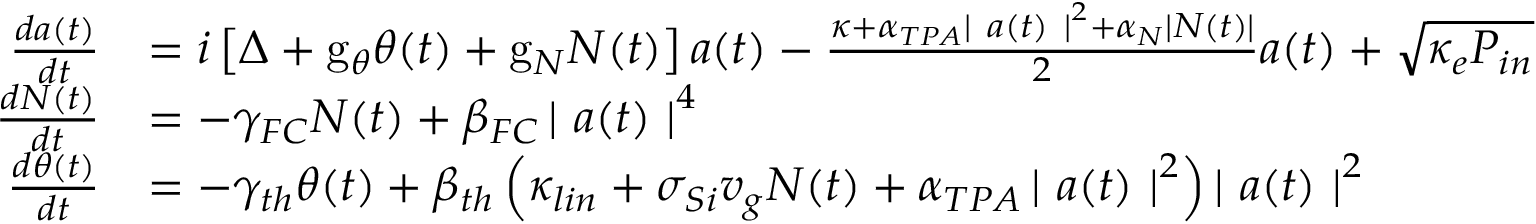Convert formula to latex. <formula><loc_0><loc_0><loc_500><loc_500>\begin{array} { r l } { \frac { d a ( t ) } { d t } } & { = i \left [ \Delta + g _ { \theta } \theta ( t ) + g _ { N } N ( t ) \right ] a ( t ) - \frac { \kappa + \alpha _ { T P A } \left | a ( t ) \right | ^ { 2 } + \alpha _ { N } \left | N ( t ) \right | } { 2 } a ( t ) + \sqrt { \kappa _ { e } P _ { i n } } } \\ { \frac { d N ( t ) } { d t } } & { = - \gamma _ { F C } N ( t ) + \beta _ { F C } \left | a ( t ) \right | ^ { 4 } } \\ { \frac { d \theta ( t ) } { d t } } & { = - \gamma _ { t h } \theta ( t ) + \beta _ { t h } \left ( \kappa _ { l i n } + \sigma _ { S i } v _ { g } N ( t ) + \alpha _ { T P A } \left | a ( t ) \right | ^ { 2 } \right ) \left | a ( t ) \right | ^ { 2 } } \end{array}</formula> 